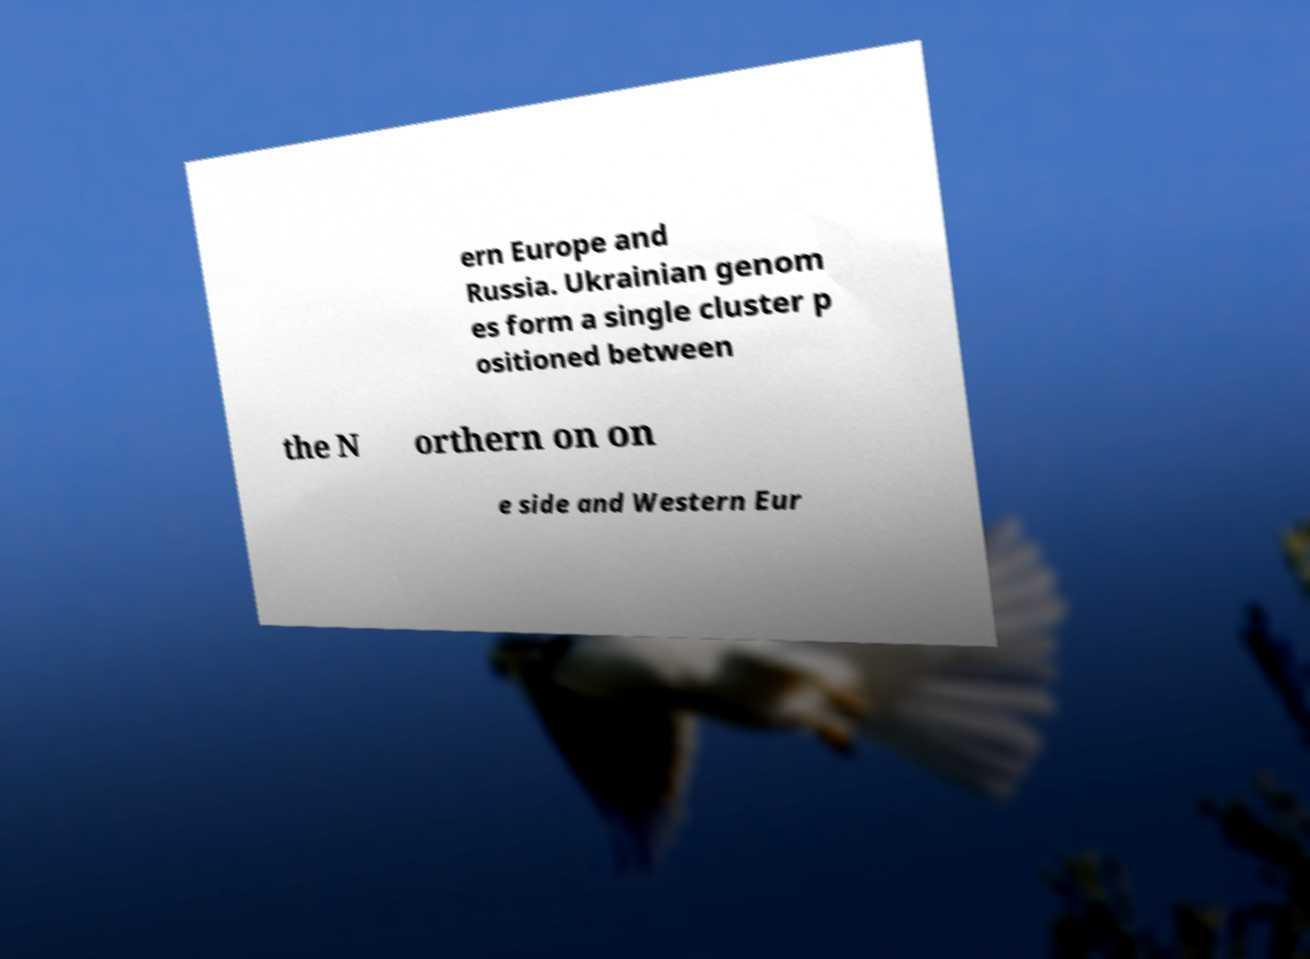For documentation purposes, I need the text within this image transcribed. Could you provide that? ern Europe and Russia. Ukrainian genom es form a single cluster p ositioned between the N orthern on on e side and Western Eur 